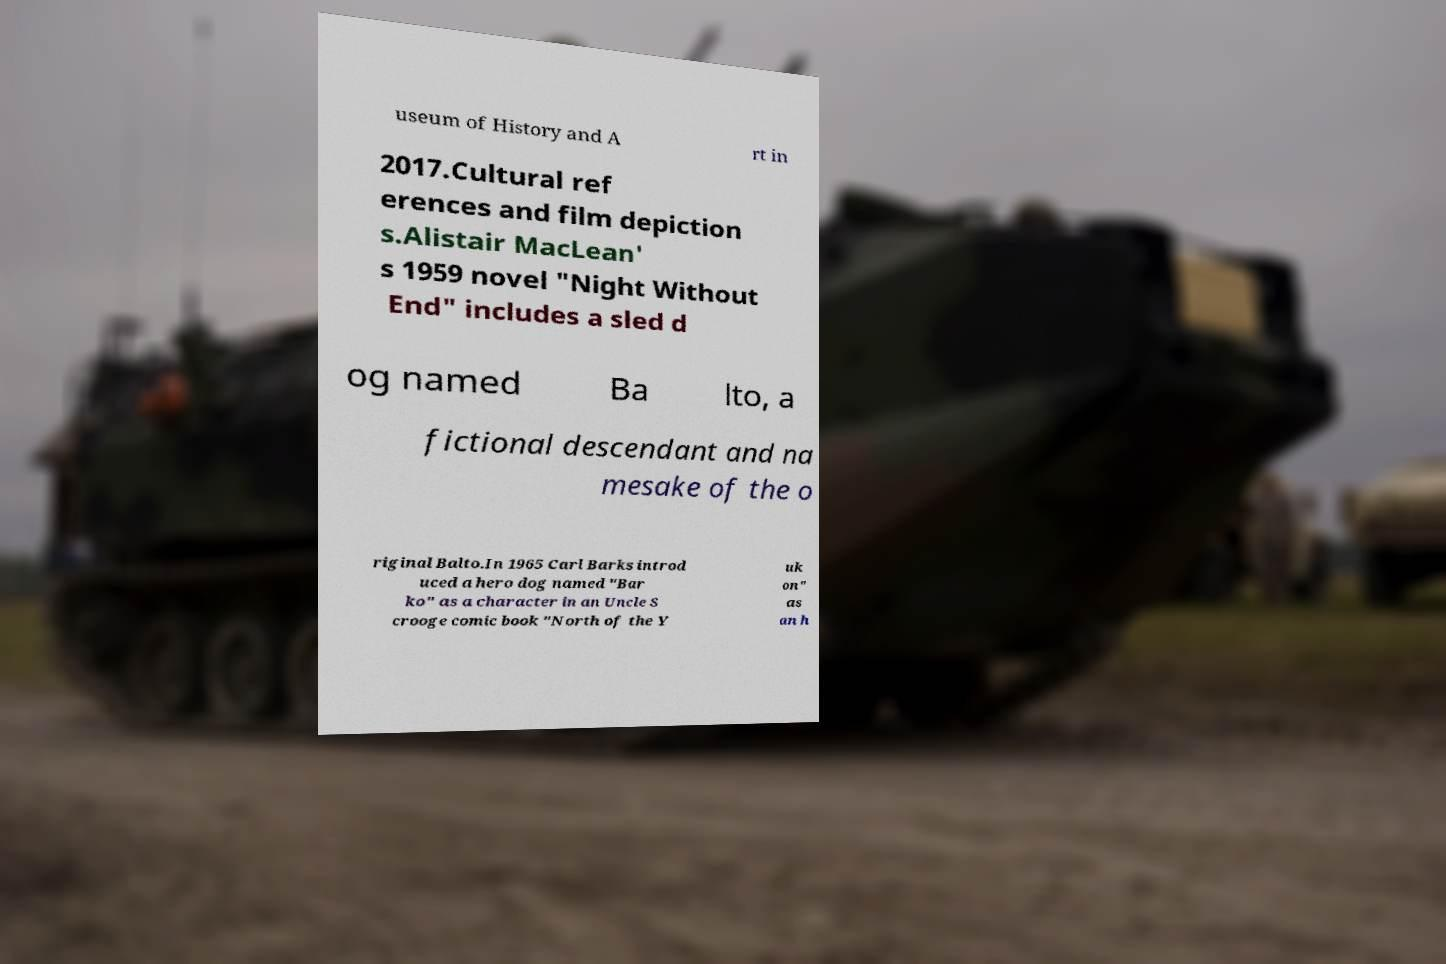Could you extract and type out the text from this image? useum of History and A rt in 2017.Cultural ref erences and film depiction s.Alistair MacLean' s 1959 novel "Night Without End" includes a sled d og named Ba lto, a fictional descendant and na mesake of the o riginal Balto.In 1965 Carl Barks introd uced a hero dog named "Bar ko" as a character in an Uncle S crooge comic book "North of the Y uk on" as an h 